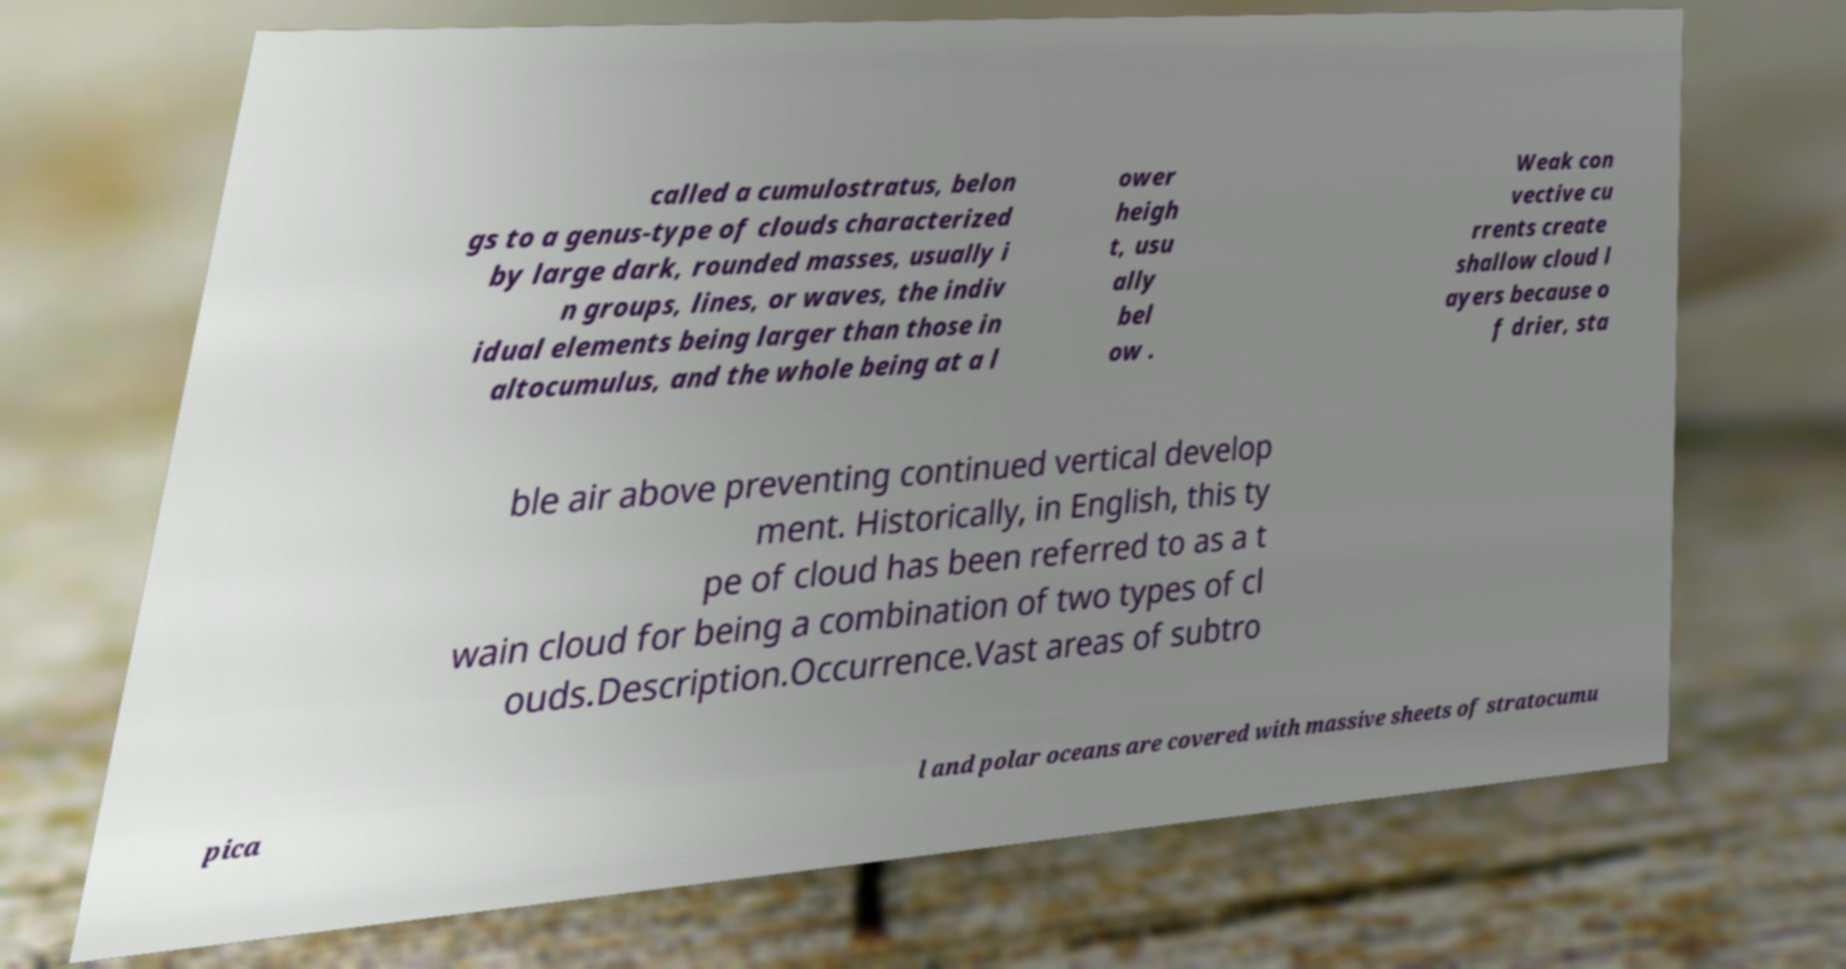Please read and relay the text visible in this image. What does it say? called a cumulostratus, belon gs to a genus-type of clouds characterized by large dark, rounded masses, usually i n groups, lines, or waves, the indiv idual elements being larger than those in altocumulus, and the whole being at a l ower heigh t, usu ally bel ow . Weak con vective cu rrents create shallow cloud l ayers because o f drier, sta ble air above preventing continued vertical develop ment. Historically, in English, this ty pe of cloud has been referred to as a t wain cloud for being a combination of two types of cl ouds.Description.Occurrence.Vast areas of subtro pica l and polar oceans are covered with massive sheets of stratocumu 